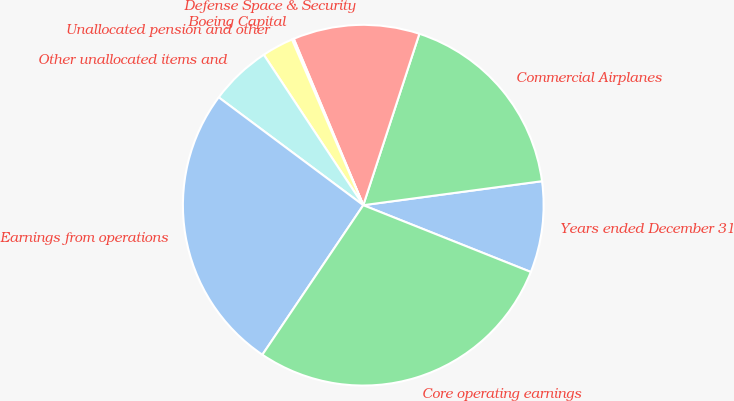<chart> <loc_0><loc_0><loc_500><loc_500><pie_chart><fcel>Years ended December 31<fcel>Commercial Airplanes<fcel>Defense Space & Security<fcel>Boeing Capital<fcel>Unallocated pension and other<fcel>Other unallocated items and<fcel>Earnings from operations<fcel>Core operating earnings<nl><fcel>8.16%<fcel>17.84%<fcel>11.33%<fcel>0.17%<fcel>2.83%<fcel>5.5%<fcel>25.75%<fcel>28.41%<nl></chart> 